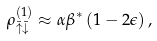<formula> <loc_0><loc_0><loc_500><loc_500>\rho _ { \bar { \uparrow } \bar { \downarrow } } ^ { ( 1 ) } \approx \alpha \beta ^ { \ast } \left ( 1 - 2 \epsilon \right ) ,</formula> 